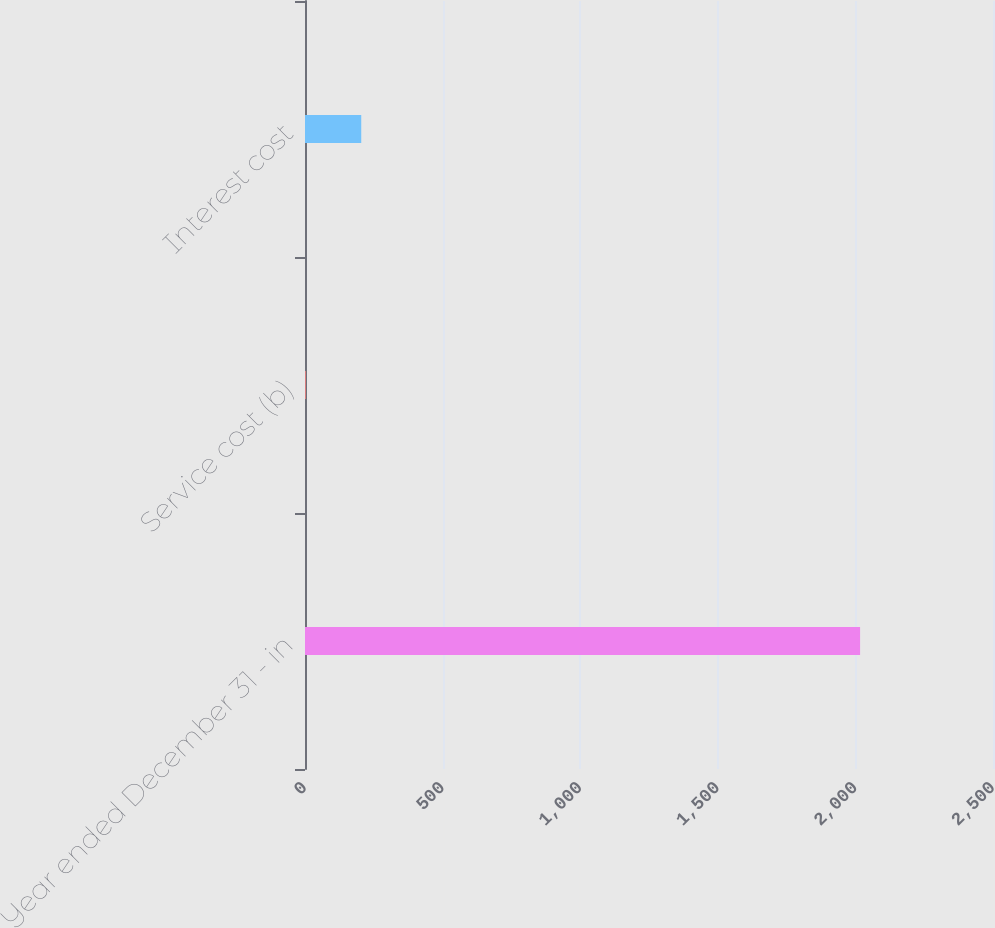<chart> <loc_0><loc_0><loc_500><loc_500><bar_chart><fcel>Year ended December 31 - in<fcel>Service cost (b)<fcel>Interest cost<nl><fcel>2017<fcel>3<fcel>204.4<nl></chart> 